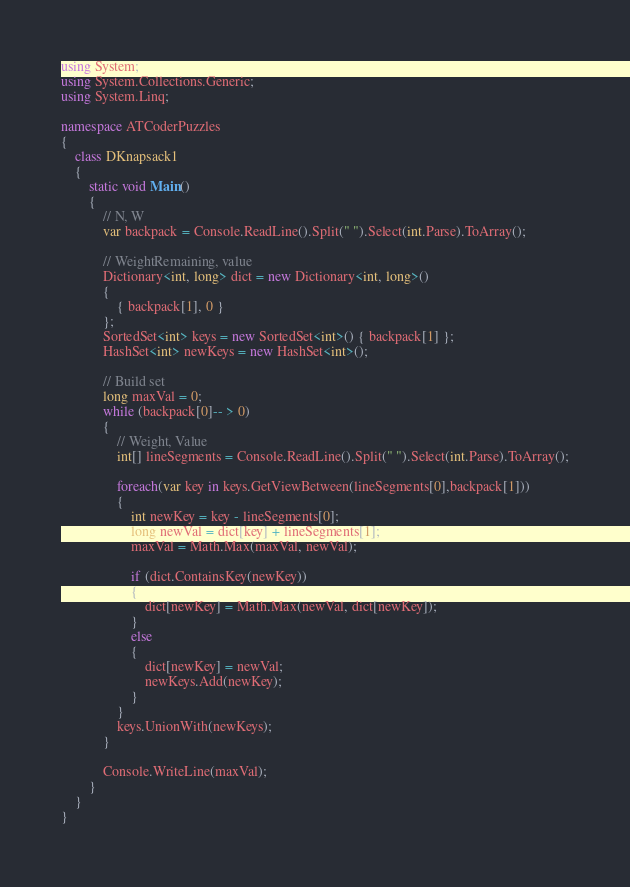Convert code to text. <code><loc_0><loc_0><loc_500><loc_500><_C#_>using System;
using System.Collections.Generic;
using System.Linq;
 
namespace ATCoderPuzzles
{
    class DKnapsack1
    {
        static void Main()
        {
            // N, W
            var backpack = Console.ReadLine().Split(" ").Select(int.Parse).ToArray();
 
            // WeightRemaining, value
            Dictionary<int, long> dict = new Dictionary<int, long>()
            {
                { backpack[1], 0 }
            };
            SortedSet<int> keys = new SortedSet<int>() { backpack[1] };
            HashSet<int> newKeys = new HashSet<int>();
 
            // Build set
            long maxVal = 0;
            while (backpack[0]-- > 0)
            {
                // Weight, Value
                int[] lineSegments = Console.ReadLine().Split(" ").Select(int.Parse).ToArray();
 
                foreach(var key in keys.GetViewBetween(lineSegments[0],backpack[1]))
                {
                    int newKey = key - lineSegments[0];
                    long newVal = dict[key] + lineSegments[1];
                    maxVal = Math.Max(maxVal, newVal);
 
                    if (dict.ContainsKey(newKey))
                    {
                        dict[newKey] = Math.Max(newVal, dict[newKey]);
                    }
                    else
                    {
                        dict[newKey] = newVal;
                        newKeys.Add(newKey);
                    }
                }
                keys.UnionWith(newKeys);
            }
 
            Console.WriteLine(maxVal);
        }
    }
}</code> 